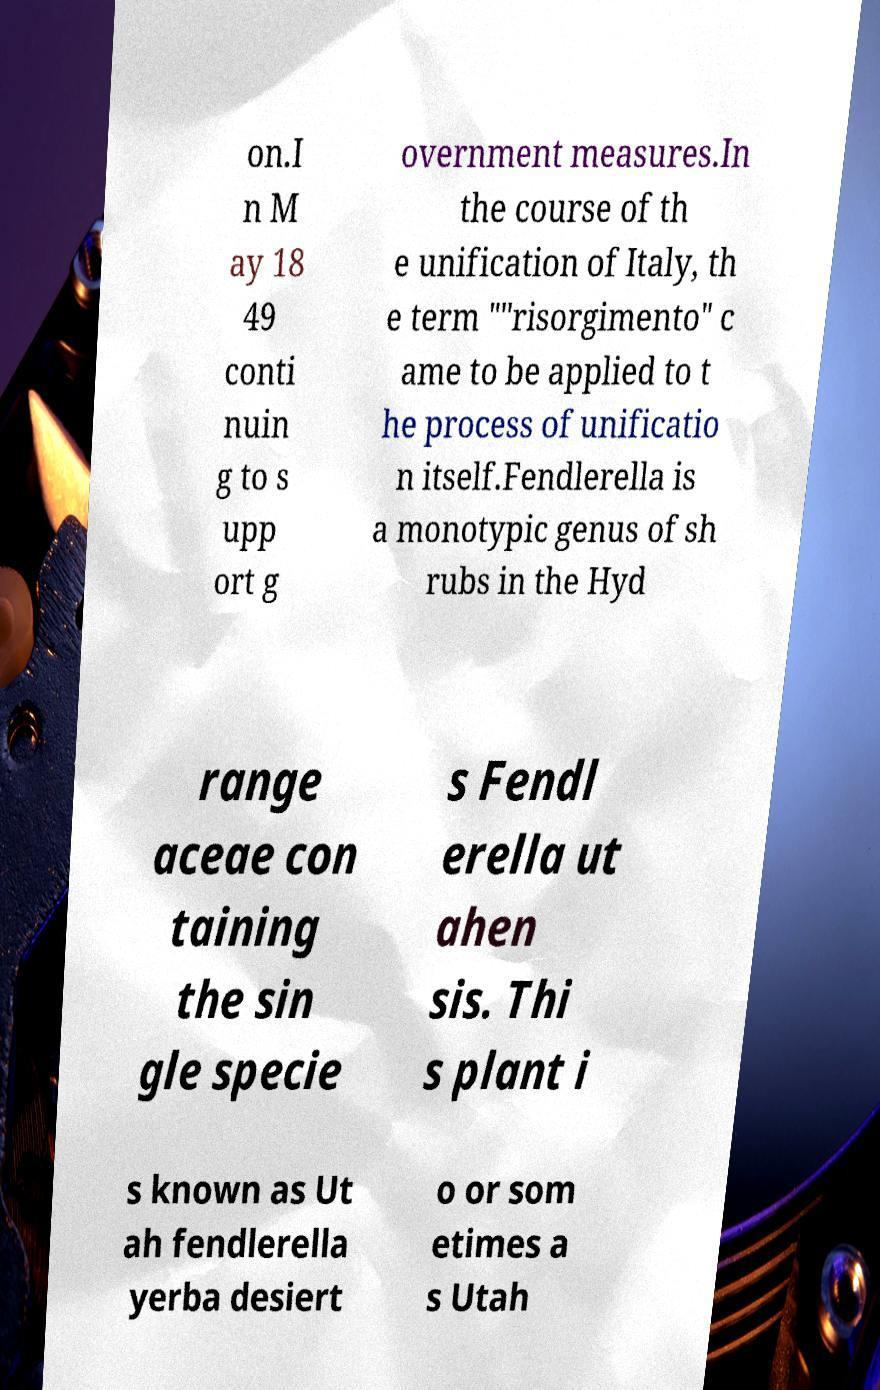What messages or text are displayed in this image? I need them in a readable, typed format. on.I n M ay 18 49 conti nuin g to s upp ort g overnment measures.In the course of th e unification of Italy, th e term ""risorgimento" c ame to be applied to t he process of unificatio n itself.Fendlerella is a monotypic genus of sh rubs in the Hyd range aceae con taining the sin gle specie s Fendl erella ut ahen sis. Thi s plant i s known as Ut ah fendlerella yerba desiert o or som etimes a s Utah 